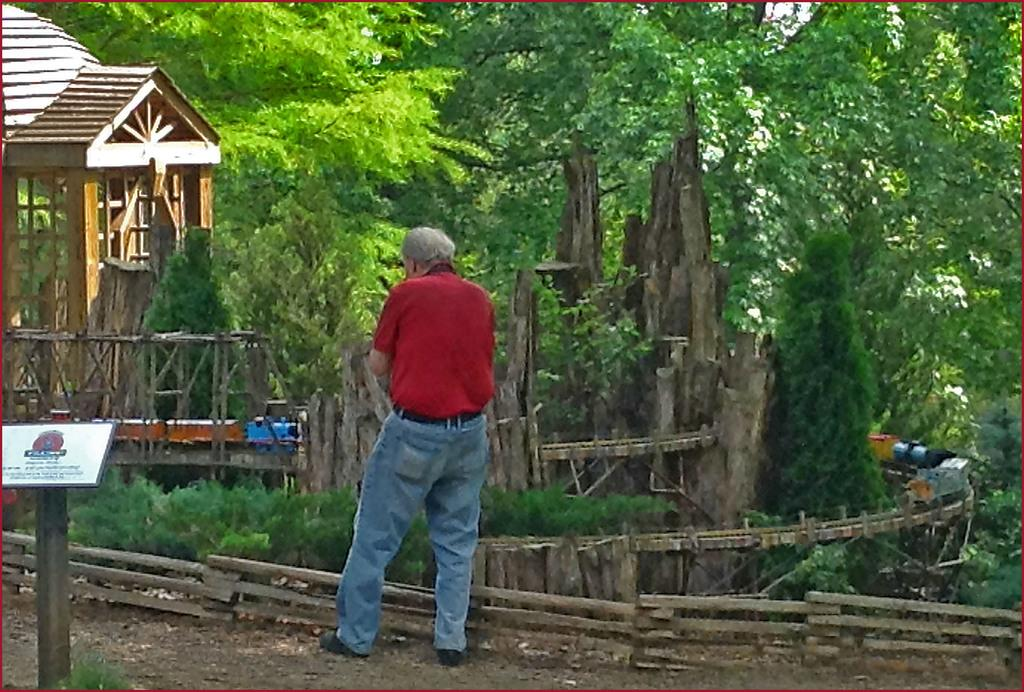What is the main subject in the image? There is a person standing in the image. What is located near the person? There is a small wooden fencing near the person. What can be seen on the left side of the image? There is a pole with a board on the left side of the image. What is visible in the background of the image? There is a wooden building and trees in the background of the image. Is the person in the image riding a bike? There is no bike present in the image. Is the person in the image shaking hands with someone? The image does not show any interaction between the person and others, so it cannot be determined if they are shaking hands. 